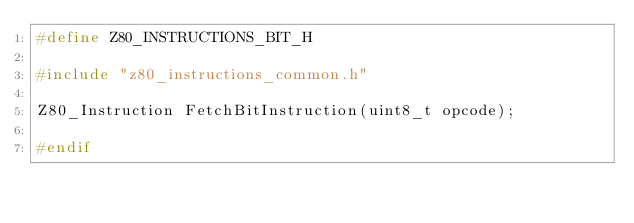<code> <loc_0><loc_0><loc_500><loc_500><_C_>#define Z80_INSTRUCTIONS_BIT_H

#include "z80_instructions_common.h"

Z80_Instruction FetchBitInstruction(uint8_t opcode);

#endif</code> 